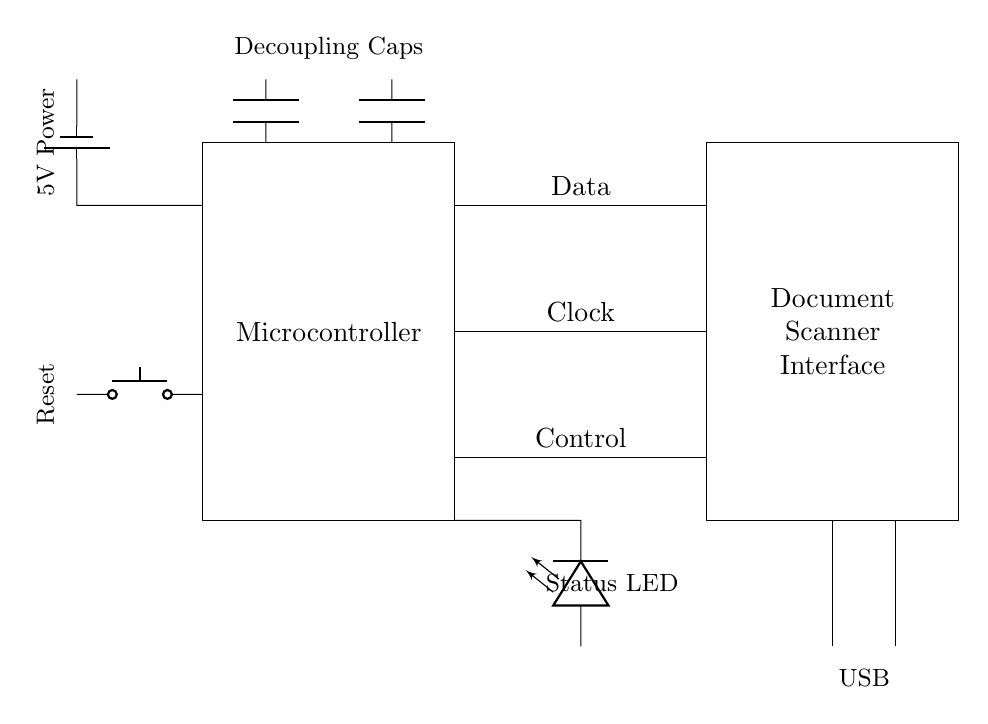What is the function of the reset button? The reset button is used to reset the microcontroller and reinitialize the circuit. It connects to the microcontroller, allowing it to restart.
Answer: Reset What type of connection is used for data communication? The connection for data communication is a direct line labeled "Data" between the microcontroller and the document scanner interface, indicating a data signal flow.
Answer: Data How many capacitors are shown in the circuit? There are two capacitors in the circuit, both labeled as decoupling capacitors located near the microcontroller for noise reduction.
Answer: 2 What is the power supply voltage? The power supply voltage is specified as 5V, indicated by the label next to the battery component at the top of the circuit.
Answer: 5V What is the purpose of the LED indicator? The LED indicator serves as a status indicator, providing visual confirmation of the device's operational state. It is connected to the output from the microcontroller.
Answer: Status LED What is the primary purpose of the microcontroller in this circuit? The primary purpose of the microcontroller is to control the document scanning process by processing data exchanged with the document scanner interface and managing overall functionality.
Answer: Control 